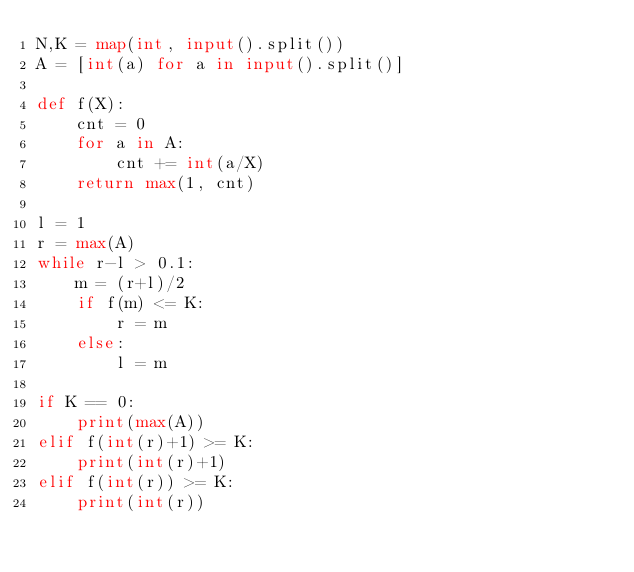Convert code to text. <code><loc_0><loc_0><loc_500><loc_500><_Python_>N,K = map(int, input().split())
A = [int(a) for a in input().split()]

def f(X):
    cnt = 0
    for a in A:
        cnt += int(a/X)
    return max(1, cnt)

l = 1
r = max(A)
while r-l > 0.1:
    m = (r+l)/2
    if f(m) <= K:
        r = m
    else:
        l = m

if K == 0:
    print(max(A))
elif f(int(r)+1) >= K:
    print(int(r)+1)
elif f(int(r)) >= K:
    print(int(r))</code> 